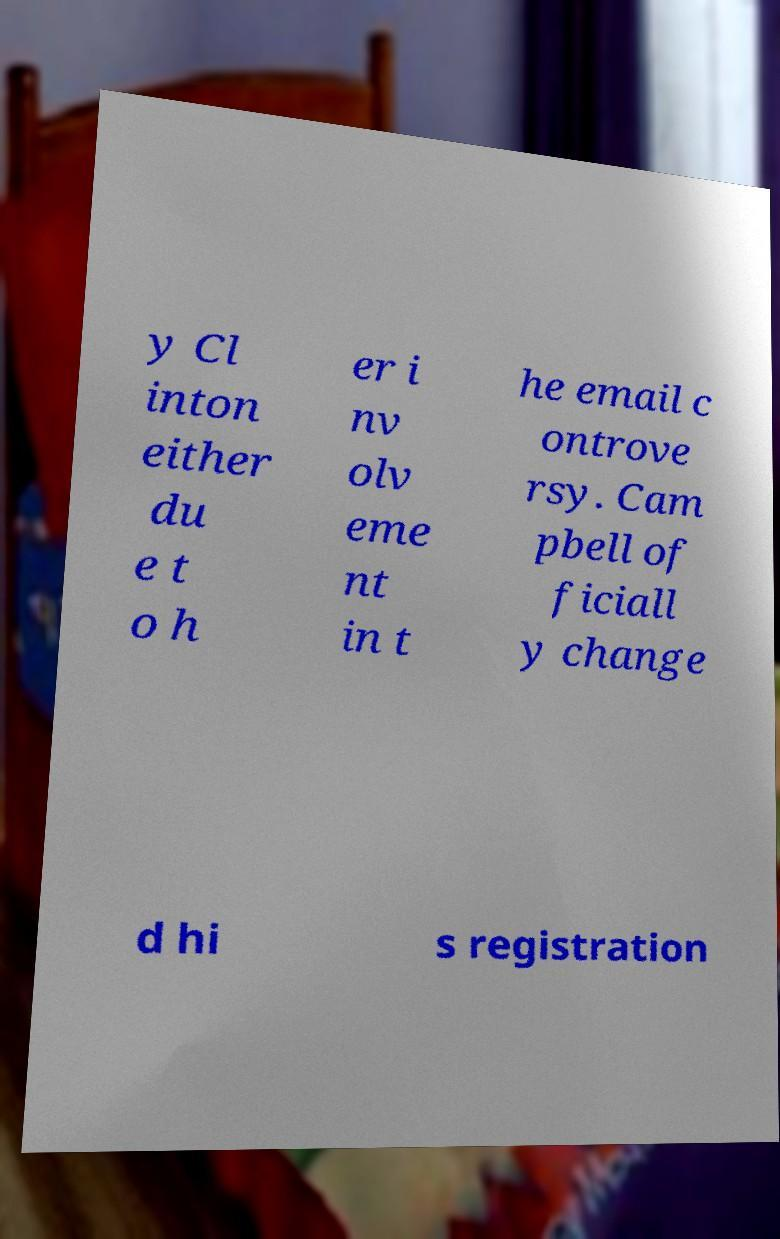There's text embedded in this image that I need extracted. Can you transcribe it verbatim? y Cl inton either du e t o h er i nv olv eme nt in t he email c ontrove rsy. Cam pbell of ficiall y change d hi s registration 